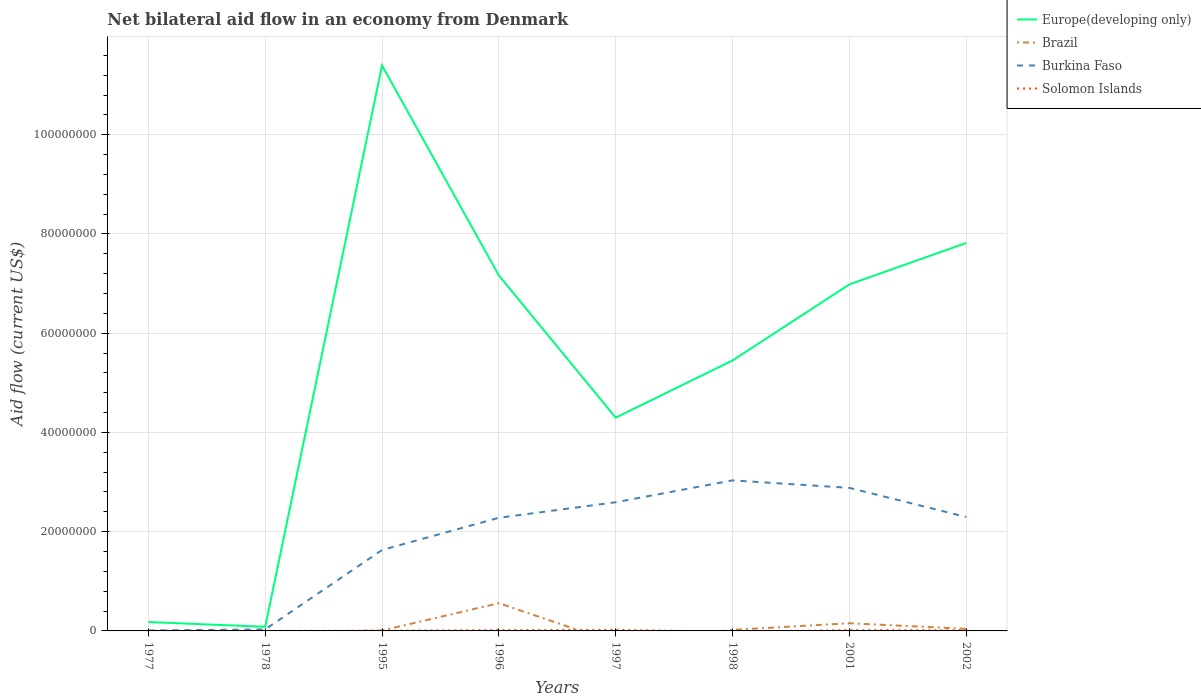Is the number of lines equal to the number of legend labels?
Make the answer very short. No. Across all years, what is the maximum net bilateral aid flow in Solomon Islands?
Keep it short and to the point. 0. What is the total net bilateral aid flow in Brazil in the graph?
Make the answer very short. -3.30e+05. What is the difference between the highest and the second highest net bilateral aid flow in Brazil?
Provide a short and direct response. 5.59e+06. Is the net bilateral aid flow in Europe(developing only) strictly greater than the net bilateral aid flow in Solomon Islands over the years?
Give a very brief answer. No. How many lines are there?
Ensure brevity in your answer.  4. Are the values on the major ticks of Y-axis written in scientific E-notation?
Offer a terse response. No. Does the graph contain grids?
Ensure brevity in your answer.  Yes. How many legend labels are there?
Your answer should be very brief. 4. What is the title of the graph?
Ensure brevity in your answer.  Net bilateral aid flow in an economy from Denmark. What is the label or title of the Y-axis?
Keep it short and to the point. Aid flow (current US$). What is the Aid flow (current US$) in Europe(developing only) in 1977?
Ensure brevity in your answer.  1.79e+06. What is the Aid flow (current US$) in Europe(developing only) in 1978?
Provide a short and direct response. 8.30e+05. What is the Aid flow (current US$) of Europe(developing only) in 1995?
Keep it short and to the point. 1.14e+08. What is the Aid flow (current US$) of Brazil in 1995?
Give a very brief answer. 9.00e+04. What is the Aid flow (current US$) in Burkina Faso in 1995?
Your answer should be compact. 1.63e+07. What is the Aid flow (current US$) in Solomon Islands in 1995?
Keep it short and to the point. 4.00e+04. What is the Aid flow (current US$) of Europe(developing only) in 1996?
Provide a succinct answer. 7.16e+07. What is the Aid flow (current US$) in Brazil in 1996?
Offer a terse response. 5.59e+06. What is the Aid flow (current US$) in Burkina Faso in 1996?
Give a very brief answer. 2.28e+07. What is the Aid flow (current US$) of Solomon Islands in 1996?
Your answer should be very brief. 1.50e+05. What is the Aid flow (current US$) in Europe(developing only) in 1997?
Give a very brief answer. 4.30e+07. What is the Aid flow (current US$) of Brazil in 1997?
Make the answer very short. 0. What is the Aid flow (current US$) of Burkina Faso in 1997?
Ensure brevity in your answer.  2.59e+07. What is the Aid flow (current US$) of Solomon Islands in 1997?
Make the answer very short. 2.10e+05. What is the Aid flow (current US$) in Europe(developing only) in 1998?
Keep it short and to the point. 5.45e+07. What is the Aid flow (current US$) of Brazil in 1998?
Ensure brevity in your answer.  2.00e+05. What is the Aid flow (current US$) of Burkina Faso in 1998?
Your response must be concise. 3.03e+07. What is the Aid flow (current US$) of Solomon Islands in 1998?
Your response must be concise. 0. What is the Aid flow (current US$) in Europe(developing only) in 2001?
Ensure brevity in your answer.  6.98e+07. What is the Aid flow (current US$) in Brazil in 2001?
Provide a succinct answer. 1.55e+06. What is the Aid flow (current US$) of Burkina Faso in 2001?
Provide a short and direct response. 2.88e+07. What is the Aid flow (current US$) in Europe(developing only) in 2002?
Your response must be concise. 7.82e+07. What is the Aid flow (current US$) of Burkina Faso in 2002?
Ensure brevity in your answer.  2.30e+07. Across all years, what is the maximum Aid flow (current US$) of Europe(developing only)?
Your answer should be compact. 1.14e+08. Across all years, what is the maximum Aid flow (current US$) in Brazil?
Make the answer very short. 5.59e+06. Across all years, what is the maximum Aid flow (current US$) in Burkina Faso?
Your answer should be very brief. 3.03e+07. Across all years, what is the minimum Aid flow (current US$) of Europe(developing only)?
Offer a terse response. 8.30e+05. Across all years, what is the minimum Aid flow (current US$) in Brazil?
Give a very brief answer. 0. Across all years, what is the minimum Aid flow (current US$) in Solomon Islands?
Ensure brevity in your answer.  0. What is the total Aid flow (current US$) of Europe(developing only) in the graph?
Your response must be concise. 4.34e+08. What is the total Aid flow (current US$) in Brazil in the graph?
Provide a succinct answer. 7.85e+06. What is the total Aid flow (current US$) in Burkina Faso in the graph?
Make the answer very short. 1.48e+08. What is the total Aid flow (current US$) of Solomon Islands in the graph?
Give a very brief answer. 7.10e+05. What is the difference between the Aid flow (current US$) in Europe(developing only) in 1977 and that in 1978?
Your response must be concise. 9.60e+05. What is the difference between the Aid flow (current US$) of Burkina Faso in 1977 and that in 1978?
Provide a succinct answer. -2.20e+05. What is the difference between the Aid flow (current US$) of Solomon Islands in 1977 and that in 1978?
Offer a terse response. 10000. What is the difference between the Aid flow (current US$) of Europe(developing only) in 1977 and that in 1995?
Keep it short and to the point. -1.12e+08. What is the difference between the Aid flow (current US$) of Burkina Faso in 1977 and that in 1995?
Give a very brief answer. -1.62e+07. What is the difference between the Aid flow (current US$) of Solomon Islands in 1977 and that in 1995?
Ensure brevity in your answer.  -2.00e+04. What is the difference between the Aid flow (current US$) in Europe(developing only) in 1977 and that in 1996?
Your answer should be very brief. -6.98e+07. What is the difference between the Aid flow (current US$) in Burkina Faso in 1977 and that in 1996?
Your response must be concise. -2.27e+07. What is the difference between the Aid flow (current US$) of Europe(developing only) in 1977 and that in 1997?
Ensure brevity in your answer.  -4.12e+07. What is the difference between the Aid flow (current US$) in Burkina Faso in 1977 and that in 1997?
Make the answer very short. -2.58e+07. What is the difference between the Aid flow (current US$) in Europe(developing only) in 1977 and that in 1998?
Keep it short and to the point. -5.27e+07. What is the difference between the Aid flow (current US$) in Burkina Faso in 1977 and that in 1998?
Your answer should be very brief. -3.02e+07. What is the difference between the Aid flow (current US$) of Europe(developing only) in 1977 and that in 2001?
Your answer should be very brief. -6.80e+07. What is the difference between the Aid flow (current US$) in Burkina Faso in 1977 and that in 2001?
Ensure brevity in your answer.  -2.87e+07. What is the difference between the Aid flow (current US$) of Solomon Islands in 1977 and that in 2001?
Your answer should be compact. -1.40e+05. What is the difference between the Aid flow (current US$) of Europe(developing only) in 1977 and that in 2002?
Ensure brevity in your answer.  -7.64e+07. What is the difference between the Aid flow (current US$) of Burkina Faso in 1977 and that in 2002?
Keep it short and to the point. -2.29e+07. What is the difference between the Aid flow (current US$) in Solomon Islands in 1977 and that in 2002?
Keep it short and to the point. -1.00e+05. What is the difference between the Aid flow (current US$) of Europe(developing only) in 1978 and that in 1995?
Make the answer very short. -1.13e+08. What is the difference between the Aid flow (current US$) of Burkina Faso in 1978 and that in 1995?
Keep it short and to the point. -1.60e+07. What is the difference between the Aid flow (current US$) in Europe(developing only) in 1978 and that in 1996?
Offer a terse response. -7.08e+07. What is the difference between the Aid flow (current US$) of Burkina Faso in 1978 and that in 1996?
Keep it short and to the point. -2.25e+07. What is the difference between the Aid flow (current US$) of Solomon Islands in 1978 and that in 1996?
Keep it short and to the point. -1.40e+05. What is the difference between the Aid flow (current US$) of Europe(developing only) in 1978 and that in 1997?
Ensure brevity in your answer.  -4.22e+07. What is the difference between the Aid flow (current US$) of Burkina Faso in 1978 and that in 1997?
Ensure brevity in your answer.  -2.56e+07. What is the difference between the Aid flow (current US$) in Solomon Islands in 1978 and that in 1997?
Your answer should be very brief. -2.00e+05. What is the difference between the Aid flow (current US$) of Europe(developing only) in 1978 and that in 1998?
Provide a short and direct response. -5.37e+07. What is the difference between the Aid flow (current US$) of Burkina Faso in 1978 and that in 1998?
Ensure brevity in your answer.  -3.00e+07. What is the difference between the Aid flow (current US$) of Europe(developing only) in 1978 and that in 2001?
Provide a succinct answer. -6.90e+07. What is the difference between the Aid flow (current US$) in Burkina Faso in 1978 and that in 2001?
Your response must be concise. -2.85e+07. What is the difference between the Aid flow (current US$) in Solomon Islands in 1978 and that in 2001?
Make the answer very short. -1.50e+05. What is the difference between the Aid flow (current US$) in Europe(developing only) in 1978 and that in 2002?
Keep it short and to the point. -7.74e+07. What is the difference between the Aid flow (current US$) in Burkina Faso in 1978 and that in 2002?
Ensure brevity in your answer.  -2.27e+07. What is the difference between the Aid flow (current US$) of Solomon Islands in 1978 and that in 2002?
Ensure brevity in your answer.  -1.10e+05. What is the difference between the Aid flow (current US$) of Europe(developing only) in 1995 and that in 1996?
Your response must be concise. 4.23e+07. What is the difference between the Aid flow (current US$) in Brazil in 1995 and that in 1996?
Give a very brief answer. -5.50e+06. What is the difference between the Aid flow (current US$) in Burkina Faso in 1995 and that in 1996?
Provide a short and direct response. -6.49e+06. What is the difference between the Aid flow (current US$) of Solomon Islands in 1995 and that in 1996?
Your response must be concise. -1.10e+05. What is the difference between the Aid flow (current US$) of Europe(developing only) in 1995 and that in 1997?
Your response must be concise. 7.10e+07. What is the difference between the Aid flow (current US$) of Burkina Faso in 1995 and that in 1997?
Offer a terse response. -9.62e+06. What is the difference between the Aid flow (current US$) in Europe(developing only) in 1995 and that in 1998?
Your response must be concise. 5.95e+07. What is the difference between the Aid flow (current US$) of Brazil in 1995 and that in 1998?
Your answer should be very brief. -1.10e+05. What is the difference between the Aid flow (current US$) of Burkina Faso in 1995 and that in 1998?
Give a very brief answer. -1.40e+07. What is the difference between the Aid flow (current US$) of Europe(developing only) in 1995 and that in 2001?
Provide a succinct answer. 4.41e+07. What is the difference between the Aid flow (current US$) of Brazil in 1995 and that in 2001?
Your answer should be compact. -1.46e+06. What is the difference between the Aid flow (current US$) in Burkina Faso in 1995 and that in 2001?
Give a very brief answer. -1.25e+07. What is the difference between the Aid flow (current US$) of Europe(developing only) in 1995 and that in 2002?
Offer a terse response. 3.58e+07. What is the difference between the Aid flow (current US$) in Brazil in 1995 and that in 2002?
Your response must be concise. -3.30e+05. What is the difference between the Aid flow (current US$) in Burkina Faso in 1995 and that in 2002?
Provide a succinct answer. -6.66e+06. What is the difference between the Aid flow (current US$) in Europe(developing only) in 1996 and that in 1997?
Your answer should be compact. 2.87e+07. What is the difference between the Aid flow (current US$) in Burkina Faso in 1996 and that in 1997?
Offer a very short reply. -3.13e+06. What is the difference between the Aid flow (current US$) of Solomon Islands in 1996 and that in 1997?
Your response must be concise. -6.00e+04. What is the difference between the Aid flow (current US$) of Europe(developing only) in 1996 and that in 1998?
Give a very brief answer. 1.71e+07. What is the difference between the Aid flow (current US$) of Brazil in 1996 and that in 1998?
Make the answer very short. 5.39e+06. What is the difference between the Aid flow (current US$) of Burkina Faso in 1996 and that in 1998?
Provide a short and direct response. -7.54e+06. What is the difference between the Aid flow (current US$) in Europe(developing only) in 1996 and that in 2001?
Your answer should be very brief. 1.81e+06. What is the difference between the Aid flow (current US$) in Brazil in 1996 and that in 2001?
Your response must be concise. 4.04e+06. What is the difference between the Aid flow (current US$) of Burkina Faso in 1996 and that in 2001?
Offer a terse response. -6.03e+06. What is the difference between the Aid flow (current US$) in Europe(developing only) in 1996 and that in 2002?
Make the answer very short. -6.54e+06. What is the difference between the Aid flow (current US$) of Brazil in 1996 and that in 2002?
Ensure brevity in your answer.  5.17e+06. What is the difference between the Aid flow (current US$) in Solomon Islands in 1996 and that in 2002?
Offer a very short reply. 3.00e+04. What is the difference between the Aid flow (current US$) of Europe(developing only) in 1997 and that in 1998?
Offer a terse response. -1.15e+07. What is the difference between the Aid flow (current US$) of Burkina Faso in 1997 and that in 1998?
Give a very brief answer. -4.41e+06. What is the difference between the Aid flow (current US$) in Europe(developing only) in 1997 and that in 2001?
Keep it short and to the point. -2.68e+07. What is the difference between the Aid flow (current US$) in Burkina Faso in 1997 and that in 2001?
Keep it short and to the point. -2.90e+06. What is the difference between the Aid flow (current US$) of Solomon Islands in 1997 and that in 2001?
Provide a short and direct response. 5.00e+04. What is the difference between the Aid flow (current US$) of Europe(developing only) in 1997 and that in 2002?
Make the answer very short. -3.52e+07. What is the difference between the Aid flow (current US$) of Burkina Faso in 1997 and that in 2002?
Keep it short and to the point. 2.96e+06. What is the difference between the Aid flow (current US$) of Solomon Islands in 1997 and that in 2002?
Provide a short and direct response. 9.00e+04. What is the difference between the Aid flow (current US$) of Europe(developing only) in 1998 and that in 2001?
Give a very brief answer. -1.53e+07. What is the difference between the Aid flow (current US$) of Brazil in 1998 and that in 2001?
Offer a terse response. -1.35e+06. What is the difference between the Aid flow (current US$) in Burkina Faso in 1998 and that in 2001?
Make the answer very short. 1.51e+06. What is the difference between the Aid flow (current US$) of Europe(developing only) in 1998 and that in 2002?
Provide a short and direct response. -2.37e+07. What is the difference between the Aid flow (current US$) of Brazil in 1998 and that in 2002?
Keep it short and to the point. -2.20e+05. What is the difference between the Aid flow (current US$) of Burkina Faso in 1998 and that in 2002?
Offer a terse response. 7.37e+06. What is the difference between the Aid flow (current US$) of Europe(developing only) in 2001 and that in 2002?
Provide a short and direct response. -8.35e+06. What is the difference between the Aid flow (current US$) of Brazil in 2001 and that in 2002?
Your answer should be compact. 1.13e+06. What is the difference between the Aid flow (current US$) of Burkina Faso in 2001 and that in 2002?
Provide a succinct answer. 5.86e+06. What is the difference between the Aid flow (current US$) in Europe(developing only) in 1977 and the Aid flow (current US$) in Burkina Faso in 1978?
Make the answer very short. 1.48e+06. What is the difference between the Aid flow (current US$) in Europe(developing only) in 1977 and the Aid flow (current US$) in Solomon Islands in 1978?
Your answer should be very brief. 1.78e+06. What is the difference between the Aid flow (current US$) in Europe(developing only) in 1977 and the Aid flow (current US$) in Brazil in 1995?
Ensure brevity in your answer.  1.70e+06. What is the difference between the Aid flow (current US$) of Europe(developing only) in 1977 and the Aid flow (current US$) of Burkina Faso in 1995?
Give a very brief answer. -1.45e+07. What is the difference between the Aid flow (current US$) of Europe(developing only) in 1977 and the Aid flow (current US$) of Solomon Islands in 1995?
Offer a very short reply. 1.75e+06. What is the difference between the Aid flow (current US$) in Europe(developing only) in 1977 and the Aid flow (current US$) in Brazil in 1996?
Offer a very short reply. -3.80e+06. What is the difference between the Aid flow (current US$) of Europe(developing only) in 1977 and the Aid flow (current US$) of Burkina Faso in 1996?
Offer a terse response. -2.10e+07. What is the difference between the Aid flow (current US$) of Europe(developing only) in 1977 and the Aid flow (current US$) of Solomon Islands in 1996?
Your answer should be compact. 1.64e+06. What is the difference between the Aid flow (current US$) in Burkina Faso in 1977 and the Aid flow (current US$) in Solomon Islands in 1996?
Your answer should be very brief. -6.00e+04. What is the difference between the Aid flow (current US$) of Europe(developing only) in 1977 and the Aid flow (current US$) of Burkina Faso in 1997?
Give a very brief answer. -2.41e+07. What is the difference between the Aid flow (current US$) of Europe(developing only) in 1977 and the Aid flow (current US$) of Solomon Islands in 1997?
Give a very brief answer. 1.58e+06. What is the difference between the Aid flow (current US$) of Europe(developing only) in 1977 and the Aid flow (current US$) of Brazil in 1998?
Your answer should be compact. 1.59e+06. What is the difference between the Aid flow (current US$) of Europe(developing only) in 1977 and the Aid flow (current US$) of Burkina Faso in 1998?
Keep it short and to the point. -2.86e+07. What is the difference between the Aid flow (current US$) in Europe(developing only) in 1977 and the Aid flow (current US$) in Burkina Faso in 2001?
Provide a short and direct response. -2.70e+07. What is the difference between the Aid flow (current US$) in Europe(developing only) in 1977 and the Aid flow (current US$) in Solomon Islands in 2001?
Your answer should be very brief. 1.63e+06. What is the difference between the Aid flow (current US$) of Burkina Faso in 1977 and the Aid flow (current US$) of Solomon Islands in 2001?
Give a very brief answer. -7.00e+04. What is the difference between the Aid flow (current US$) in Europe(developing only) in 1977 and the Aid flow (current US$) in Brazil in 2002?
Offer a terse response. 1.37e+06. What is the difference between the Aid flow (current US$) of Europe(developing only) in 1977 and the Aid flow (current US$) of Burkina Faso in 2002?
Provide a short and direct response. -2.12e+07. What is the difference between the Aid flow (current US$) of Europe(developing only) in 1977 and the Aid flow (current US$) of Solomon Islands in 2002?
Ensure brevity in your answer.  1.67e+06. What is the difference between the Aid flow (current US$) in Burkina Faso in 1977 and the Aid flow (current US$) in Solomon Islands in 2002?
Your answer should be compact. -3.00e+04. What is the difference between the Aid flow (current US$) of Europe(developing only) in 1978 and the Aid flow (current US$) of Brazil in 1995?
Provide a succinct answer. 7.40e+05. What is the difference between the Aid flow (current US$) in Europe(developing only) in 1978 and the Aid flow (current US$) in Burkina Faso in 1995?
Offer a terse response. -1.55e+07. What is the difference between the Aid flow (current US$) of Europe(developing only) in 1978 and the Aid flow (current US$) of Solomon Islands in 1995?
Provide a succinct answer. 7.90e+05. What is the difference between the Aid flow (current US$) of Europe(developing only) in 1978 and the Aid flow (current US$) of Brazil in 1996?
Provide a succinct answer. -4.76e+06. What is the difference between the Aid flow (current US$) of Europe(developing only) in 1978 and the Aid flow (current US$) of Burkina Faso in 1996?
Your answer should be very brief. -2.20e+07. What is the difference between the Aid flow (current US$) of Europe(developing only) in 1978 and the Aid flow (current US$) of Solomon Islands in 1996?
Offer a terse response. 6.80e+05. What is the difference between the Aid flow (current US$) of Burkina Faso in 1978 and the Aid flow (current US$) of Solomon Islands in 1996?
Your response must be concise. 1.60e+05. What is the difference between the Aid flow (current US$) of Europe(developing only) in 1978 and the Aid flow (current US$) of Burkina Faso in 1997?
Keep it short and to the point. -2.51e+07. What is the difference between the Aid flow (current US$) of Europe(developing only) in 1978 and the Aid flow (current US$) of Solomon Islands in 1997?
Ensure brevity in your answer.  6.20e+05. What is the difference between the Aid flow (current US$) in Europe(developing only) in 1978 and the Aid flow (current US$) in Brazil in 1998?
Make the answer very short. 6.30e+05. What is the difference between the Aid flow (current US$) in Europe(developing only) in 1978 and the Aid flow (current US$) in Burkina Faso in 1998?
Your response must be concise. -2.95e+07. What is the difference between the Aid flow (current US$) of Europe(developing only) in 1978 and the Aid flow (current US$) of Brazil in 2001?
Your answer should be very brief. -7.20e+05. What is the difference between the Aid flow (current US$) in Europe(developing only) in 1978 and the Aid flow (current US$) in Burkina Faso in 2001?
Provide a succinct answer. -2.80e+07. What is the difference between the Aid flow (current US$) of Europe(developing only) in 1978 and the Aid flow (current US$) of Solomon Islands in 2001?
Make the answer very short. 6.70e+05. What is the difference between the Aid flow (current US$) in Burkina Faso in 1978 and the Aid flow (current US$) in Solomon Islands in 2001?
Offer a terse response. 1.50e+05. What is the difference between the Aid flow (current US$) in Europe(developing only) in 1978 and the Aid flow (current US$) in Brazil in 2002?
Offer a terse response. 4.10e+05. What is the difference between the Aid flow (current US$) of Europe(developing only) in 1978 and the Aid flow (current US$) of Burkina Faso in 2002?
Your response must be concise. -2.21e+07. What is the difference between the Aid flow (current US$) in Europe(developing only) in 1978 and the Aid flow (current US$) in Solomon Islands in 2002?
Your answer should be very brief. 7.10e+05. What is the difference between the Aid flow (current US$) in Burkina Faso in 1978 and the Aid flow (current US$) in Solomon Islands in 2002?
Ensure brevity in your answer.  1.90e+05. What is the difference between the Aid flow (current US$) of Europe(developing only) in 1995 and the Aid flow (current US$) of Brazil in 1996?
Offer a terse response. 1.08e+08. What is the difference between the Aid flow (current US$) in Europe(developing only) in 1995 and the Aid flow (current US$) in Burkina Faso in 1996?
Provide a short and direct response. 9.12e+07. What is the difference between the Aid flow (current US$) of Europe(developing only) in 1995 and the Aid flow (current US$) of Solomon Islands in 1996?
Give a very brief answer. 1.14e+08. What is the difference between the Aid flow (current US$) of Brazil in 1995 and the Aid flow (current US$) of Burkina Faso in 1996?
Your answer should be compact. -2.27e+07. What is the difference between the Aid flow (current US$) of Brazil in 1995 and the Aid flow (current US$) of Solomon Islands in 1996?
Keep it short and to the point. -6.00e+04. What is the difference between the Aid flow (current US$) in Burkina Faso in 1995 and the Aid flow (current US$) in Solomon Islands in 1996?
Ensure brevity in your answer.  1.62e+07. What is the difference between the Aid flow (current US$) of Europe(developing only) in 1995 and the Aid flow (current US$) of Burkina Faso in 1997?
Your answer should be very brief. 8.80e+07. What is the difference between the Aid flow (current US$) in Europe(developing only) in 1995 and the Aid flow (current US$) in Solomon Islands in 1997?
Your response must be concise. 1.14e+08. What is the difference between the Aid flow (current US$) of Brazil in 1995 and the Aid flow (current US$) of Burkina Faso in 1997?
Give a very brief answer. -2.58e+07. What is the difference between the Aid flow (current US$) in Brazil in 1995 and the Aid flow (current US$) in Solomon Islands in 1997?
Provide a short and direct response. -1.20e+05. What is the difference between the Aid flow (current US$) in Burkina Faso in 1995 and the Aid flow (current US$) in Solomon Islands in 1997?
Your answer should be very brief. 1.61e+07. What is the difference between the Aid flow (current US$) in Europe(developing only) in 1995 and the Aid flow (current US$) in Brazil in 1998?
Your response must be concise. 1.14e+08. What is the difference between the Aid flow (current US$) in Europe(developing only) in 1995 and the Aid flow (current US$) in Burkina Faso in 1998?
Offer a very short reply. 8.36e+07. What is the difference between the Aid flow (current US$) in Brazil in 1995 and the Aid flow (current US$) in Burkina Faso in 1998?
Provide a short and direct response. -3.02e+07. What is the difference between the Aid flow (current US$) of Europe(developing only) in 1995 and the Aid flow (current US$) of Brazil in 2001?
Provide a short and direct response. 1.12e+08. What is the difference between the Aid flow (current US$) of Europe(developing only) in 1995 and the Aid flow (current US$) of Burkina Faso in 2001?
Offer a very short reply. 8.51e+07. What is the difference between the Aid flow (current US$) in Europe(developing only) in 1995 and the Aid flow (current US$) in Solomon Islands in 2001?
Offer a very short reply. 1.14e+08. What is the difference between the Aid flow (current US$) in Brazil in 1995 and the Aid flow (current US$) in Burkina Faso in 2001?
Your answer should be very brief. -2.87e+07. What is the difference between the Aid flow (current US$) in Burkina Faso in 1995 and the Aid flow (current US$) in Solomon Islands in 2001?
Offer a terse response. 1.62e+07. What is the difference between the Aid flow (current US$) of Europe(developing only) in 1995 and the Aid flow (current US$) of Brazil in 2002?
Offer a very short reply. 1.14e+08. What is the difference between the Aid flow (current US$) in Europe(developing only) in 1995 and the Aid flow (current US$) in Burkina Faso in 2002?
Your answer should be compact. 9.10e+07. What is the difference between the Aid flow (current US$) in Europe(developing only) in 1995 and the Aid flow (current US$) in Solomon Islands in 2002?
Your answer should be very brief. 1.14e+08. What is the difference between the Aid flow (current US$) in Brazil in 1995 and the Aid flow (current US$) in Burkina Faso in 2002?
Your answer should be very brief. -2.29e+07. What is the difference between the Aid flow (current US$) in Burkina Faso in 1995 and the Aid flow (current US$) in Solomon Islands in 2002?
Ensure brevity in your answer.  1.62e+07. What is the difference between the Aid flow (current US$) of Europe(developing only) in 1996 and the Aid flow (current US$) of Burkina Faso in 1997?
Give a very brief answer. 4.57e+07. What is the difference between the Aid flow (current US$) of Europe(developing only) in 1996 and the Aid flow (current US$) of Solomon Islands in 1997?
Offer a terse response. 7.14e+07. What is the difference between the Aid flow (current US$) of Brazil in 1996 and the Aid flow (current US$) of Burkina Faso in 1997?
Offer a very short reply. -2.03e+07. What is the difference between the Aid flow (current US$) of Brazil in 1996 and the Aid flow (current US$) of Solomon Islands in 1997?
Provide a succinct answer. 5.38e+06. What is the difference between the Aid flow (current US$) in Burkina Faso in 1996 and the Aid flow (current US$) in Solomon Islands in 1997?
Your answer should be compact. 2.26e+07. What is the difference between the Aid flow (current US$) in Europe(developing only) in 1996 and the Aid flow (current US$) in Brazil in 1998?
Your answer should be very brief. 7.14e+07. What is the difference between the Aid flow (current US$) of Europe(developing only) in 1996 and the Aid flow (current US$) of Burkina Faso in 1998?
Ensure brevity in your answer.  4.13e+07. What is the difference between the Aid flow (current US$) in Brazil in 1996 and the Aid flow (current US$) in Burkina Faso in 1998?
Keep it short and to the point. -2.48e+07. What is the difference between the Aid flow (current US$) in Europe(developing only) in 1996 and the Aid flow (current US$) in Brazil in 2001?
Your response must be concise. 7.01e+07. What is the difference between the Aid flow (current US$) in Europe(developing only) in 1996 and the Aid flow (current US$) in Burkina Faso in 2001?
Provide a succinct answer. 4.28e+07. What is the difference between the Aid flow (current US$) of Europe(developing only) in 1996 and the Aid flow (current US$) of Solomon Islands in 2001?
Give a very brief answer. 7.15e+07. What is the difference between the Aid flow (current US$) in Brazil in 1996 and the Aid flow (current US$) in Burkina Faso in 2001?
Ensure brevity in your answer.  -2.32e+07. What is the difference between the Aid flow (current US$) of Brazil in 1996 and the Aid flow (current US$) of Solomon Islands in 2001?
Offer a terse response. 5.43e+06. What is the difference between the Aid flow (current US$) of Burkina Faso in 1996 and the Aid flow (current US$) of Solomon Islands in 2001?
Your response must be concise. 2.26e+07. What is the difference between the Aid flow (current US$) of Europe(developing only) in 1996 and the Aid flow (current US$) of Brazil in 2002?
Give a very brief answer. 7.12e+07. What is the difference between the Aid flow (current US$) of Europe(developing only) in 1996 and the Aid flow (current US$) of Burkina Faso in 2002?
Your answer should be very brief. 4.87e+07. What is the difference between the Aid flow (current US$) of Europe(developing only) in 1996 and the Aid flow (current US$) of Solomon Islands in 2002?
Provide a succinct answer. 7.15e+07. What is the difference between the Aid flow (current US$) in Brazil in 1996 and the Aid flow (current US$) in Burkina Faso in 2002?
Keep it short and to the point. -1.74e+07. What is the difference between the Aid flow (current US$) in Brazil in 1996 and the Aid flow (current US$) in Solomon Islands in 2002?
Give a very brief answer. 5.47e+06. What is the difference between the Aid flow (current US$) of Burkina Faso in 1996 and the Aid flow (current US$) of Solomon Islands in 2002?
Ensure brevity in your answer.  2.27e+07. What is the difference between the Aid flow (current US$) of Europe(developing only) in 1997 and the Aid flow (current US$) of Brazil in 1998?
Provide a succinct answer. 4.28e+07. What is the difference between the Aid flow (current US$) in Europe(developing only) in 1997 and the Aid flow (current US$) in Burkina Faso in 1998?
Provide a short and direct response. 1.26e+07. What is the difference between the Aid flow (current US$) in Europe(developing only) in 1997 and the Aid flow (current US$) in Brazil in 2001?
Provide a short and direct response. 4.14e+07. What is the difference between the Aid flow (current US$) in Europe(developing only) in 1997 and the Aid flow (current US$) in Burkina Faso in 2001?
Your answer should be very brief. 1.42e+07. What is the difference between the Aid flow (current US$) of Europe(developing only) in 1997 and the Aid flow (current US$) of Solomon Islands in 2001?
Provide a short and direct response. 4.28e+07. What is the difference between the Aid flow (current US$) in Burkina Faso in 1997 and the Aid flow (current US$) in Solomon Islands in 2001?
Make the answer very short. 2.58e+07. What is the difference between the Aid flow (current US$) in Europe(developing only) in 1997 and the Aid flow (current US$) in Brazil in 2002?
Your response must be concise. 4.26e+07. What is the difference between the Aid flow (current US$) of Europe(developing only) in 1997 and the Aid flow (current US$) of Burkina Faso in 2002?
Your answer should be very brief. 2.00e+07. What is the difference between the Aid flow (current US$) of Europe(developing only) in 1997 and the Aid flow (current US$) of Solomon Islands in 2002?
Offer a very short reply. 4.29e+07. What is the difference between the Aid flow (current US$) in Burkina Faso in 1997 and the Aid flow (current US$) in Solomon Islands in 2002?
Provide a succinct answer. 2.58e+07. What is the difference between the Aid flow (current US$) in Europe(developing only) in 1998 and the Aid flow (current US$) in Brazil in 2001?
Offer a terse response. 5.30e+07. What is the difference between the Aid flow (current US$) in Europe(developing only) in 1998 and the Aid flow (current US$) in Burkina Faso in 2001?
Make the answer very short. 2.57e+07. What is the difference between the Aid flow (current US$) in Europe(developing only) in 1998 and the Aid flow (current US$) in Solomon Islands in 2001?
Offer a terse response. 5.43e+07. What is the difference between the Aid flow (current US$) in Brazil in 1998 and the Aid flow (current US$) in Burkina Faso in 2001?
Keep it short and to the point. -2.86e+07. What is the difference between the Aid flow (current US$) of Brazil in 1998 and the Aid flow (current US$) of Solomon Islands in 2001?
Offer a very short reply. 4.00e+04. What is the difference between the Aid flow (current US$) in Burkina Faso in 1998 and the Aid flow (current US$) in Solomon Islands in 2001?
Ensure brevity in your answer.  3.02e+07. What is the difference between the Aid flow (current US$) of Europe(developing only) in 1998 and the Aid flow (current US$) of Brazil in 2002?
Your answer should be compact. 5.41e+07. What is the difference between the Aid flow (current US$) in Europe(developing only) in 1998 and the Aid flow (current US$) in Burkina Faso in 2002?
Make the answer very short. 3.15e+07. What is the difference between the Aid flow (current US$) in Europe(developing only) in 1998 and the Aid flow (current US$) in Solomon Islands in 2002?
Your response must be concise. 5.44e+07. What is the difference between the Aid flow (current US$) of Brazil in 1998 and the Aid flow (current US$) of Burkina Faso in 2002?
Give a very brief answer. -2.28e+07. What is the difference between the Aid flow (current US$) of Brazil in 1998 and the Aid flow (current US$) of Solomon Islands in 2002?
Your answer should be compact. 8.00e+04. What is the difference between the Aid flow (current US$) of Burkina Faso in 1998 and the Aid flow (current US$) of Solomon Islands in 2002?
Offer a terse response. 3.02e+07. What is the difference between the Aid flow (current US$) in Europe(developing only) in 2001 and the Aid flow (current US$) in Brazil in 2002?
Provide a short and direct response. 6.94e+07. What is the difference between the Aid flow (current US$) of Europe(developing only) in 2001 and the Aid flow (current US$) of Burkina Faso in 2002?
Give a very brief answer. 4.69e+07. What is the difference between the Aid flow (current US$) of Europe(developing only) in 2001 and the Aid flow (current US$) of Solomon Islands in 2002?
Your answer should be very brief. 6.97e+07. What is the difference between the Aid flow (current US$) of Brazil in 2001 and the Aid flow (current US$) of Burkina Faso in 2002?
Keep it short and to the point. -2.14e+07. What is the difference between the Aid flow (current US$) in Brazil in 2001 and the Aid flow (current US$) in Solomon Islands in 2002?
Keep it short and to the point. 1.43e+06. What is the difference between the Aid flow (current US$) in Burkina Faso in 2001 and the Aid flow (current US$) in Solomon Islands in 2002?
Offer a very short reply. 2.87e+07. What is the average Aid flow (current US$) in Europe(developing only) per year?
Give a very brief answer. 5.42e+07. What is the average Aid flow (current US$) of Brazil per year?
Your response must be concise. 9.81e+05. What is the average Aid flow (current US$) of Burkina Faso per year?
Offer a terse response. 1.84e+07. What is the average Aid flow (current US$) in Solomon Islands per year?
Make the answer very short. 8.88e+04. In the year 1977, what is the difference between the Aid flow (current US$) in Europe(developing only) and Aid flow (current US$) in Burkina Faso?
Provide a short and direct response. 1.70e+06. In the year 1977, what is the difference between the Aid flow (current US$) in Europe(developing only) and Aid flow (current US$) in Solomon Islands?
Make the answer very short. 1.77e+06. In the year 1977, what is the difference between the Aid flow (current US$) in Burkina Faso and Aid flow (current US$) in Solomon Islands?
Make the answer very short. 7.00e+04. In the year 1978, what is the difference between the Aid flow (current US$) in Europe(developing only) and Aid flow (current US$) in Burkina Faso?
Ensure brevity in your answer.  5.20e+05. In the year 1978, what is the difference between the Aid flow (current US$) of Europe(developing only) and Aid flow (current US$) of Solomon Islands?
Your response must be concise. 8.20e+05. In the year 1995, what is the difference between the Aid flow (current US$) in Europe(developing only) and Aid flow (current US$) in Brazil?
Keep it short and to the point. 1.14e+08. In the year 1995, what is the difference between the Aid flow (current US$) in Europe(developing only) and Aid flow (current US$) in Burkina Faso?
Your answer should be very brief. 9.76e+07. In the year 1995, what is the difference between the Aid flow (current US$) of Europe(developing only) and Aid flow (current US$) of Solomon Islands?
Your answer should be very brief. 1.14e+08. In the year 1995, what is the difference between the Aid flow (current US$) of Brazil and Aid flow (current US$) of Burkina Faso?
Keep it short and to the point. -1.62e+07. In the year 1995, what is the difference between the Aid flow (current US$) in Burkina Faso and Aid flow (current US$) in Solomon Islands?
Ensure brevity in your answer.  1.63e+07. In the year 1996, what is the difference between the Aid flow (current US$) in Europe(developing only) and Aid flow (current US$) in Brazil?
Your answer should be very brief. 6.60e+07. In the year 1996, what is the difference between the Aid flow (current US$) in Europe(developing only) and Aid flow (current US$) in Burkina Faso?
Your response must be concise. 4.88e+07. In the year 1996, what is the difference between the Aid flow (current US$) in Europe(developing only) and Aid flow (current US$) in Solomon Islands?
Offer a terse response. 7.15e+07. In the year 1996, what is the difference between the Aid flow (current US$) of Brazil and Aid flow (current US$) of Burkina Faso?
Your answer should be very brief. -1.72e+07. In the year 1996, what is the difference between the Aid flow (current US$) in Brazil and Aid flow (current US$) in Solomon Islands?
Your response must be concise. 5.44e+06. In the year 1996, what is the difference between the Aid flow (current US$) in Burkina Faso and Aid flow (current US$) in Solomon Islands?
Give a very brief answer. 2.26e+07. In the year 1997, what is the difference between the Aid flow (current US$) in Europe(developing only) and Aid flow (current US$) in Burkina Faso?
Provide a short and direct response. 1.70e+07. In the year 1997, what is the difference between the Aid flow (current US$) in Europe(developing only) and Aid flow (current US$) in Solomon Islands?
Make the answer very short. 4.28e+07. In the year 1997, what is the difference between the Aid flow (current US$) of Burkina Faso and Aid flow (current US$) of Solomon Islands?
Provide a short and direct response. 2.57e+07. In the year 1998, what is the difference between the Aid flow (current US$) in Europe(developing only) and Aid flow (current US$) in Brazil?
Provide a short and direct response. 5.43e+07. In the year 1998, what is the difference between the Aid flow (current US$) of Europe(developing only) and Aid flow (current US$) of Burkina Faso?
Provide a succinct answer. 2.42e+07. In the year 1998, what is the difference between the Aid flow (current US$) of Brazil and Aid flow (current US$) of Burkina Faso?
Your answer should be compact. -3.01e+07. In the year 2001, what is the difference between the Aid flow (current US$) in Europe(developing only) and Aid flow (current US$) in Brazil?
Offer a terse response. 6.83e+07. In the year 2001, what is the difference between the Aid flow (current US$) of Europe(developing only) and Aid flow (current US$) of Burkina Faso?
Offer a very short reply. 4.10e+07. In the year 2001, what is the difference between the Aid flow (current US$) of Europe(developing only) and Aid flow (current US$) of Solomon Islands?
Offer a terse response. 6.97e+07. In the year 2001, what is the difference between the Aid flow (current US$) in Brazil and Aid flow (current US$) in Burkina Faso?
Make the answer very short. -2.73e+07. In the year 2001, what is the difference between the Aid flow (current US$) of Brazil and Aid flow (current US$) of Solomon Islands?
Your answer should be very brief. 1.39e+06. In the year 2001, what is the difference between the Aid flow (current US$) of Burkina Faso and Aid flow (current US$) of Solomon Islands?
Ensure brevity in your answer.  2.87e+07. In the year 2002, what is the difference between the Aid flow (current US$) of Europe(developing only) and Aid flow (current US$) of Brazil?
Make the answer very short. 7.78e+07. In the year 2002, what is the difference between the Aid flow (current US$) in Europe(developing only) and Aid flow (current US$) in Burkina Faso?
Make the answer very short. 5.52e+07. In the year 2002, what is the difference between the Aid flow (current US$) of Europe(developing only) and Aid flow (current US$) of Solomon Islands?
Make the answer very short. 7.81e+07. In the year 2002, what is the difference between the Aid flow (current US$) of Brazil and Aid flow (current US$) of Burkina Faso?
Your answer should be compact. -2.26e+07. In the year 2002, what is the difference between the Aid flow (current US$) of Burkina Faso and Aid flow (current US$) of Solomon Islands?
Your answer should be very brief. 2.28e+07. What is the ratio of the Aid flow (current US$) of Europe(developing only) in 1977 to that in 1978?
Give a very brief answer. 2.16. What is the ratio of the Aid flow (current US$) in Burkina Faso in 1977 to that in 1978?
Offer a terse response. 0.29. What is the ratio of the Aid flow (current US$) in Solomon Islands in 1977 to that in 1978?
Provide a succinct answer. 2. What is the ratio of the Aid flow (current US$) in Europe(developing only) in 1977 to that in 1995?
Your answer should be compact. 0.02. What is the ratio of the Aid flow (current US$) of Burkina Faso in 1977 to that in 1995?
Ensure brevity in your answer.  0.01. What is the ratio of the Aid flow (current US$) of Europe(developing only) in 1977 to that in 1996?
Provide a succinct answer. 0.03. What is the ratio of the Aid flow (current US$) of Burkina Faso in 1977 to that in 1996?
Offer a terse response. 0. What is the ratio of the Aid flow (current US$) in Solomon Islands in 1977 to that in 1996?
Your answer should be compact. 0.13. What is the ratio of the Aid flow (current US$) of Europe(developing only) in 1977 to that in 1997?
Offer a very short reply. 0.04. What is the ratio of the Aid flow (current US$) of Burkina Faso in 1977 to that in 1997?
Ensure brevity in your answer.  0. What is the ratio of the Aid flow (current US$) in Solomon Islands in 1977 to that in 1997?
Your answer should be very brief. 0.1. What is the ratio of the Aid flow (current US$) of Europe(developing only) in 1977 to that in 1998?
Keep it short and to the point. 0.03. What is the ratio of the Aid flow (current US$) in Burkina Faso in 1977 to that in 1998?
Ensure brevity in your answer.  0. What is the ratio of the Aid flow (current US$) of Europe(developing only) in 1977 to that in 2001?
Provide a succinct answer. 0.03. What is the ratio of the Aid flow (current US$) in Burkina Faso in 1977 to that in 2001?
Keep it short and to the point. 0. What is the ratio of the Aid flow (current US$) in Europe(developing only) in 1977 to that in 2002?
Your answer should be very brief. 0.02. What is the ratio of the Aid flow (current US$) in Burkina Faso in 1977 to that in 2002?
Your response must be concise. 0. What is the ratio of the Aid flow (current US$) in Solomon Islands in 1977 to that in 2002?
Provide a succinct answer. 0.17. What is the ratio of the Aid flow (current US$) of Europe(developing only) in 1978 to that in 1995?
Give a very brief answer. 0.01. What is the ratio of the Aid flow (current US$) of Burkina Faso in 1978 to that in 1995?
Provide a short and direct response. 0.02. What is the ratio of the Aid flow (current US$) of Solomon Islands in 1978 to that in 1995?
Provide a succinct answer. 0.25. What is the ratio of the Aid flow (current US$) in Europe(developing only) in 1978 to that in 1996?
Make the answer very short. 0.01. What is the ratio of the Aid flow (current US$) of Burkina Faso in 1978 to that in 1996?
Offer a very short reply. 0.01. What is the ratio of the Aid flow (current US$) in Solomon Islands in 1978 to that in 1996?
Your answer should be very brief. 0.07. What is the ratio of the Aid flow (current US$) in Europe(developing only) in 1978 to that in 1997?
Offer a terse response. 0.02. What is the ratio of the Aid flow (current US$) in Burkina Faso in 1978 to that in 1997?
Give a very brief answer. 0.01. What is the ratio of the Aid flow (current US$) in Solomon Islands in 1978 to that in 1997?
Make the answer very short. 0.05. What is the ratio of the Aid flow (current US$) of Europe(developing only) in 1978 to that in 1998?
Ensure brevity in your answer.  0.02. What is the ratio of the Aid flow (current US$) in Burkina Faso in 1978 to that in 1998?
Provide a short and direct response. 0.01. What is the ratio of the Aid flow (current US$) of Europe(developing only) in 1978 to that in 2001?
Offer a very short reply. 0.01. What is the ratio of the Aid flow (current US$) of Burkina Faso in 1978 to that in 2001?
Offer a very short reply. 0.01. What is the ratio of the Aid flow (current US$) of Solomon Islands in 1978 to that in 2001?
Your answer should be very brief. 0.06. What is the ratio of the Aid flow (current US$) in Europe(developing only) in 1978 to that in 2002?
Offer a terse response. 0.01. What is the ratio of the Aid flow (current US$) in Burkina Faso in 1978 to that in 2002?
Your response must be concise. 0.01. What is the ratio of the Aid flow (current US$) of Solomon Islands in 1978 to that in 2002?
Your answer should be compact. 0.08. What is the ratio of the Aid flow (current US$) in Europe(developing only) in 1995 to that in 1996?
Your answer should be compact. 1.59. What is the ratio of the Aid flow (current US$) of Brazil in 1995 to that in 1996?
Your answer should be very brief. 0.02. What is the ratio of the Aid flow (current US$) of Burkina Faso in 1995 to that in 1996?
Your answer should be compact. 0.72. What is the ratio of the Aid flow (current US$) in Solomon Islands in 1995 to that in 1996?
Give a very brief answer. 0.27. What is the ratio of the Aid flow (current US$) in Europe(developing only) in 1995 to that in 1997?
Provide a short and direct response. 2.65. What is the ratio of the Aid flow (current US$) of Burkina Faso in 1995 to that in 1997?
Your response must be concise. 0.63. What is the ratio of the Aid flow (current US$) in Solomon Islands in 1995 to that in 1997?
Offer a terse response. 0.19. What is the ratio of the Aid flow (current US$) in Europe(developing only) in 1995 to that in 1998?
Give a very brief answer. 2.09. What is the ratio of the Aid flow (current US$) of Brazil in 1995 to that in 1998?
Your answer should be very brief. 0.45. What is the ratio of the Aid flow (current US$) in Burkina Faso in 1995 to that in 1998?
Your answer should be compact. 0.54. What is the ratio of the Aid flow (current US$) of Europe(developing only) in 1995 to that in 2001?
Offer a terse response. 1.63. What is the ratio of the Aid flow (current US$) of Brazil in 1995 to that in 2001?
Your answer should be very brief. 0.06. What is the ratio of the Aid flow (current US$) in Burkina Faso in 1995 to that in 2001?
Ensure brevity in your answer.  0.57. What is the ratio of the Aid flow (current US$) in Europe(developing only) in 1995 to that in 2002?
Offer a very short reply. 1.46. What is the ratio of the Aid flow (current US$) in Brazil in 1995 to that in 2002?
Your answer should be compact. 0.21. What is the ratio of the Aid flow (current US$) in Burkina Faso in 1995 to that in 2002?
Provide a succinct answer. 0.71. What is the ratio of the Aid flow (current US$) in Solomon Islands in 1995 to that in 2002?
Your answer should be compact. 0.33. What is the ratio of the Aid flow (current US$) in Europe(developing only) in 1996 to that in 1997?
Offer a terse response. 1.67. What is the ratio of the Aid flow (current US$) in Burkina Faso in 1996 to that in 1997?
Ensure brevity in your answer.  0.88. What is the ratio of the Aid flow (current US$) in Europe(developing only) in 1996 to that in 1998?
Your response must be concise. 1.31. What is the ratio of the Aid flow (current US$) of Brazil in 1996 to that in 1998?
Offer a terse response. 27.95. What is the ratio of the Aid flow (current US$) of Burkina Faso in 1996 to that in 1998?
Make the answer very short. 0.75. What is the ratio of the Aid flow (current US$) of Europe(developing only) in 1996 to that in 2001?
Keep it short and to the point. 1.03. What is the ratio of the Aid flow (current US$) of Brazil in 1996 to that in 2001?
Provide a short and direct response. 3.61. What is the ratio of the Aid flow (current US$) of Burkina Faso in 1996 to that in 2001?
Ensure brevity in your answer.  0.79. What is the ratio of the Aid flow (current US$) in Solomon Islands in 1996 to that in 2001?
Provide a short and direct response. 0.94. What is the ratio of the Aid flow (current US$) of Europe(developing only) in 1996 to that in 2002?
Your answer should be very brief. 0.92. What is the ratio of the Aid flow (current US$) in Brazil in 1996 to that in 2002?
Your answer should be very brief. 13.31. What is the ratio of the Aid flow (current US$) of Solomon Islands in 1996 to that in 2002?
Make the answer very short. 1.25. What is the ratio of the Aid flow (current US$) in Europe(developing only) in 1997 to that in 1998?
Provide a succinct answer. 0.79. What is the ratio of the Aid flow (current US$) of Burkina Faso in 1997 to that in 1998?
Your response must be concise. 0.85. What is the ratio of the Aid flow (current US$) in Europe(developing only) in 1997 to that in 2001?
Ensure brevity in your answer.  0.62. What is the ratio of the Aid flow (current US$) of Burkina Faso in 1997 to that in 2001?
Provide a short and direct response. 0.9. What is the ratio of the Aid flow (current US$) in Solomon Islands in 1997 to that in 2001?
Provide a succinct answer. 1.31. What is the ratio of the Aid flow (current US$) in Europe(developing only) in 1997 to that in 2002?
Your answer should be compact. 0.55. What is the ratio of the Aid flow (current US$) in Burkina Faso in 1997 to that in 2002?
Give a very brief answer. 1.13. What is the ratio of the Aid flow (current US$) in Europe(developing only) in 1998 to that in 2001?
Your response must be concise. 0.78. What is the ratio of the Aid flow (current US$) of Brazil in 1998 to that in 2001?
Keep it short and to the point. 0.13. What is the ratio of the Aid flow (current US$) of Burkina Faso in 1998 to that in 2001?
Offer a very short reply. 1.05. What is the ratio of the Aid flow (current US$) in Europe(developing only) in 1998 to that in 2002?
Make the answer very short. 0.7. What is the ratio of the Aid flow (current US$) in Brazil in 1998 to that in 2002?
Offer a very short reply. 0.48. What is the ratio of the Aid flow (current US$) in Burkina Faso in 1998 to that in 2002?
Offer a very short reply. 1.32. What is the ratio of the Aid flow (current US$) of Europe(developing only) in 2001 to that in 2002?
Give a very brief answer. 0.89. What is the ratio of the Aid flow (current US$) of Brazil in 2001 to that in 2002?
Make the answer very short. 3.69. What is the ratio of the Aid flow (current US$) in Burkina Faso in 2001 to that in 2002?
Ensure brevity in your answer.  1.26. What is the difference between the highest and the second highest Aid flow (current US$) in Europe(developing only)?
Provide a short and direct response. 3.58e+07. What is the difference between the highest and the second highest Aid flow (current US$) of Brazil?
Provide a succinct answer. 4.04e+06. What is the difference between the highest and the second highest Aid flow (current US$) in Burkina Faso?
Offer a terse response. 1.51e+06. What is the difference between the highest and the lowest Aid flow (current US$) in Europe(developing only)?
Offer a very short reply. 1.13e+08. What is the difference between the highest and the lowest Aid flow (current US$) in Brazil?
Offer a terse response. 5.59e+06. What is the difference between the highest and the lowest Aid flow (current US$) of Burkina Faso?
Your answer should be compact. 3.02e+07. 